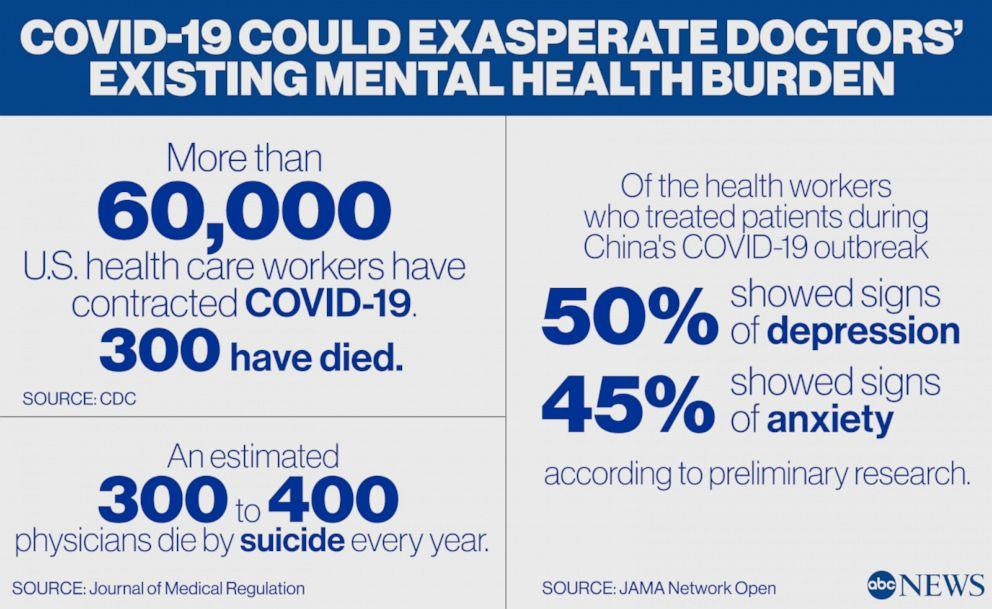Specify some key components in this picture. According to a recent study, 45% of the health workers who treated patients during China's COVID-19 outbreak showed signs of anxiety. According to a recent study, it was found that 50% of the health workers who treated patients during China's COVID-19 outbreak have shown signs of depression. 